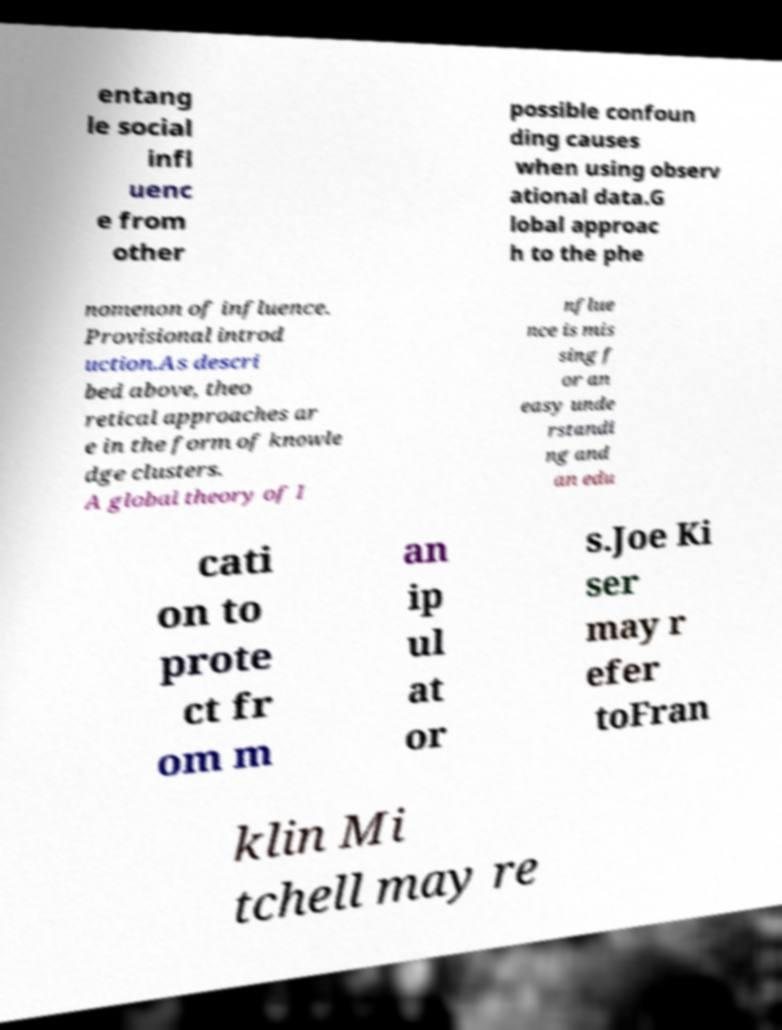For documentation purposes, I need the text within this image transcribed. Could you provide that? entang le social infl uenc e from other possible confoun ding causes when using observ ational data.G lobal approac h to the phe nomenon of influence. Provisional introd uction.As descri bed above, theo retical approaches ar e in the form of knowle dge clusters. A global theory of I nflue nce is mis sing f or an easy unde rstandi ng and an edu cati on to prote ct fr om m an ip ul at or s.Joe Ki ser may r efer toFran klin Mi tchell may re 